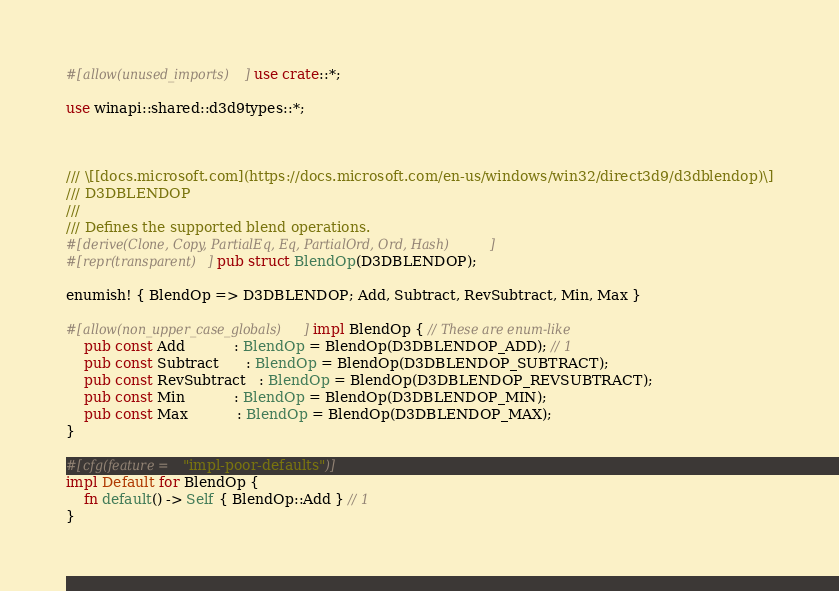Convert code to text. <code><loc_0><loc_0><loc_500><loc_500><_Rust_>#[allow(unused_imports)] use crate::*;

use winapi::shared::d3d9types::*;



/// \[[docs.microsoft.com](https://docs.microsoft.com/en-us/windows/win32/direct3d9/d3dblendop)\]
/// D3DBLENDOP
///
/// Defines the supported blend operations.
#[derive(Clone, Copy, PartialEq, Eq, PartialOrd, Ord, Hash)]
#[repr(transparent)] pub struct BlendOp(D3DBLENDOP);

enumish! { BlendOp => D3DBLENDOP; Add, Subtract, RevSubtract, Min, Max }

#[allow(non_upper_case_globals)] impl BlendOp { // These are enum-like
    pub const Add           : BlendOp = BlendOp(D3DBLENDOP_ADD); // 1
    pub const Subtract      : BlendOp = BlendOp(D3DBLENDOP_SUBTRACT);
    pub const RevSubtract   : BlendOp = BlendOp(D3DBLENDOP_REVSUBTRACT);
    pub const Min           : BlendOp = BlendOp(D3DBLENDOP_MIN);
    pub const Max           : BlendOp = BlendOp(D3DBLENDOP_MAX);
}

#[cfg(feature = "impl-poor-defaults")]
impl Default for BlendOp {
    fn default() -> Self { BlendOp::Add } // 1
}
</code> 